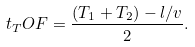<formula> <loc_0><loc_0><loc_500><loc_500>t _ { T } O F = \frac { ( T _ { 1 } + T _ { 2 } ) - l / v } { 2 } .</formula> 